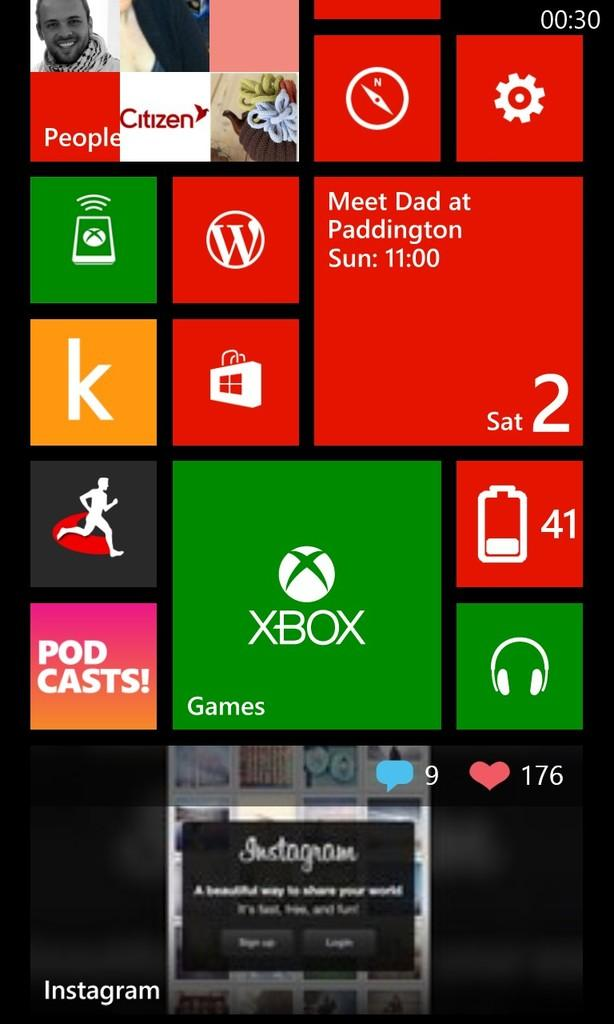<image>
Relay a brief, clear account of the picture shown. A cell phone screen showing many notifications and apps, including an appointment to meet Dad at Paddington on Sunday at 11:00. 